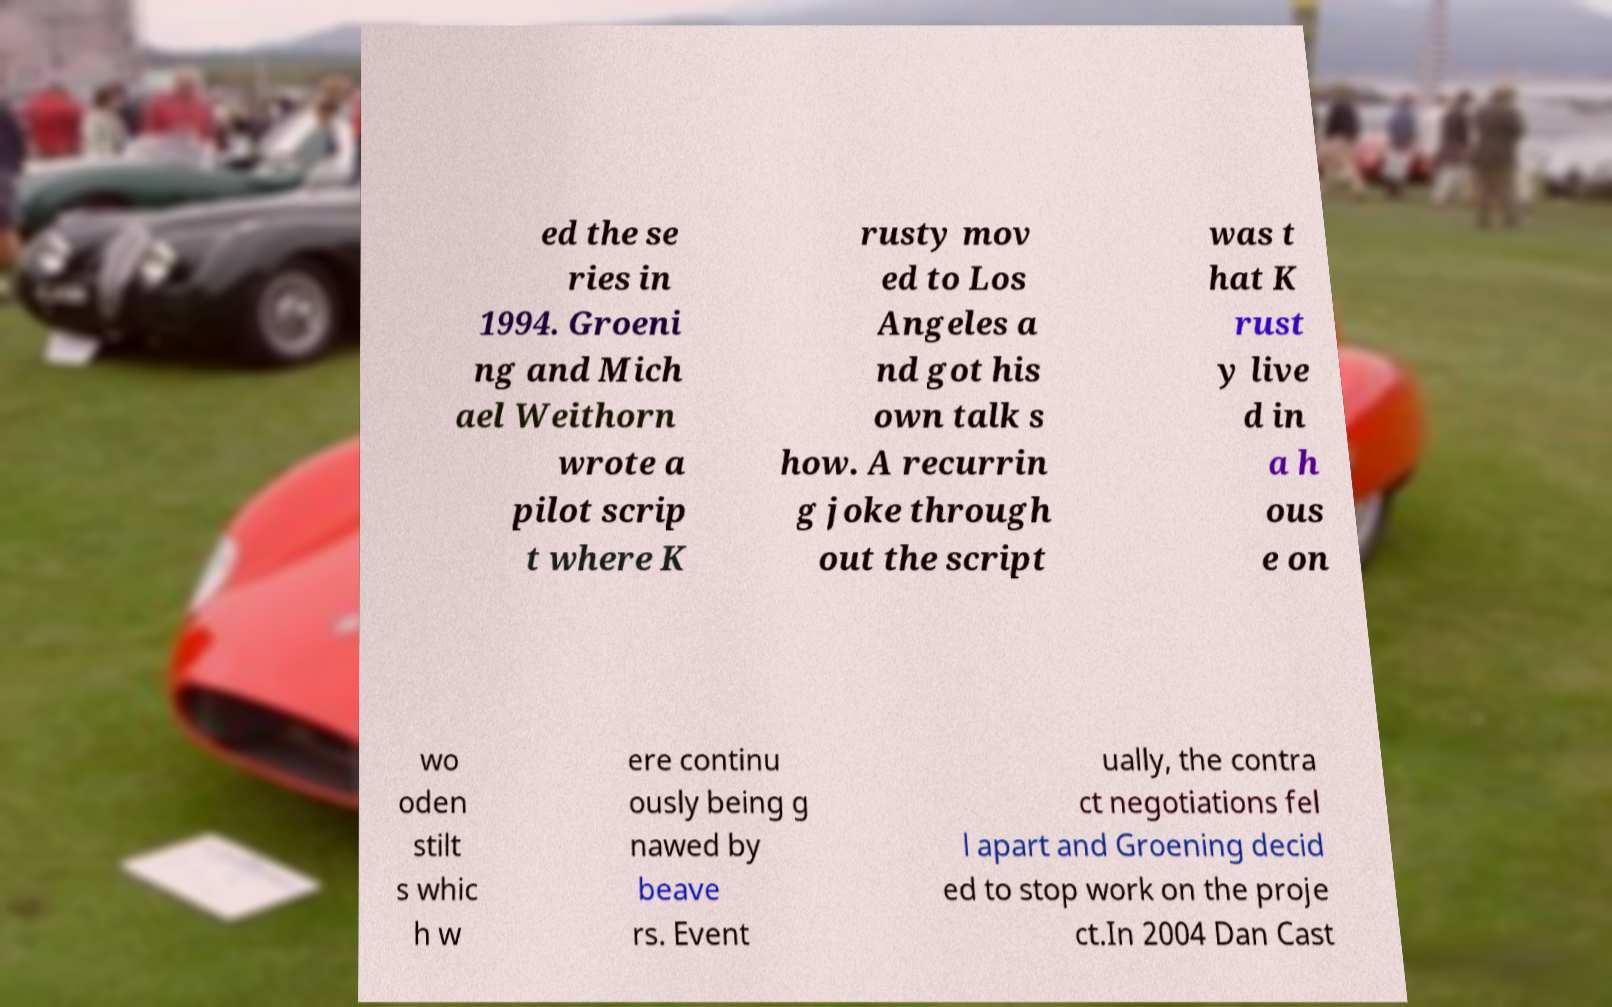There's text embedded in this image that I need extracted. Can you transcribe it verbatim? ed the se ries in 1994. Groeni ng and Mich ael Weithorn wrote a pilot scrip t where K rusty mov ed to Los Angeles a nd got his own talk s how. A recurrin g joke through out the script was t hat K rust y live d in a h ous e on wo oden stilt s whic h w ere continu ously being g nawed by beave rs. Event ually, the contra ct negotiations fel l apart and Groening decid ed to stop work on the proje ct.In 2004 Dan Cast 